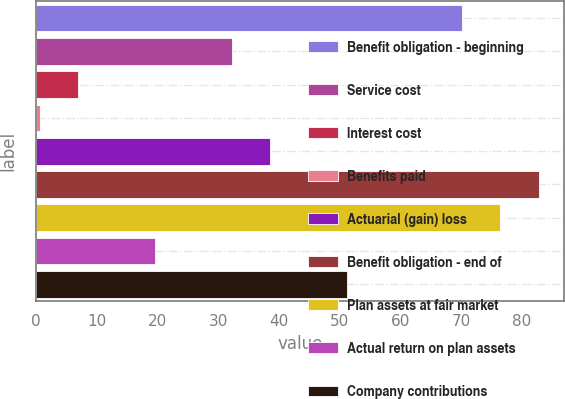<chart> <loc_0><loc_0><loc_500><loc_500><bar_chart><fcel>Benefit obligation - beginning<fcel>Service cost<fcel>Interest cost<fcel>Benefits paid<fcel>Actuarial (gain) loss<fcel>Benefit obligation - end of<fcel>Plan assets at fair market<fcel>Actual return on plan assets<fcel>Company contributions<nl><fcel>70.12<fcel>32.2<fcel>6.92<fcel>0.6<fcel>38.52<fcel>82.76<fcel>76.44<fcel>19.56<fcel>51.16<nl></chart> 